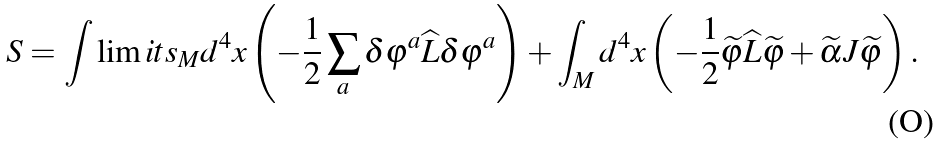Convert formula to latex. <formula><loc_0><loc_0><loc_500><loc_500>S = \int \lim i t s _ { M } d ^ { 4 } x \left ( - \frac { 1 } { 2 } \sum _ { a } \delta \varphi ^ { a } \widehat { L } \delta \varphi ^ { a } \right ) + \int _ { M } d ^ { 4 } x \left ( - \frac { 1 } { 2 } \widetilde { \varphi } \widehat { L } \widetilde { \varphi } + \widetilde { \alpha } J \widetilde { \varphi } \right ) .</formula> 